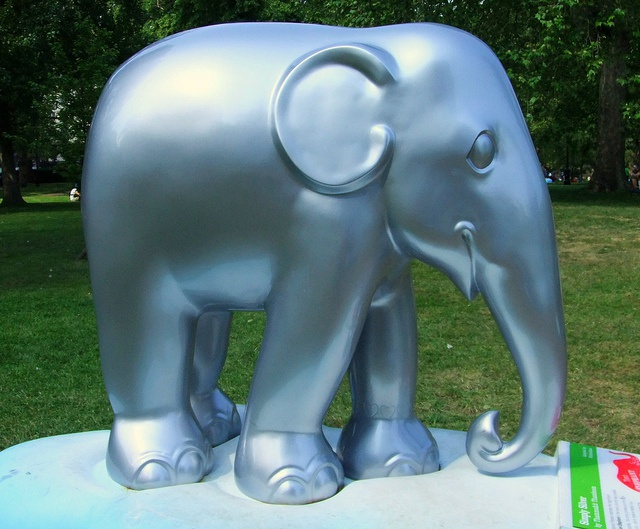Describe the objects in this image and their specific colors. I can see elephant in black, blue, gray, and lightblue tones and people in black, white, gray, and tan tones in this image. 